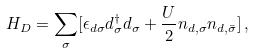Convert formula to latex. <formula><loc_0><loc_0><loc_500><loc_500>H _ { D } = \sum _ { \sigma } [ \epsilon _ { d \sigma } d _ { \sigma } ^ { \dagger } d _ { \sigma } + \frac { U } { 2 } n _ { d , \sigma } n _ { d , \bar { \sigma } } ] \, ,</formula> 